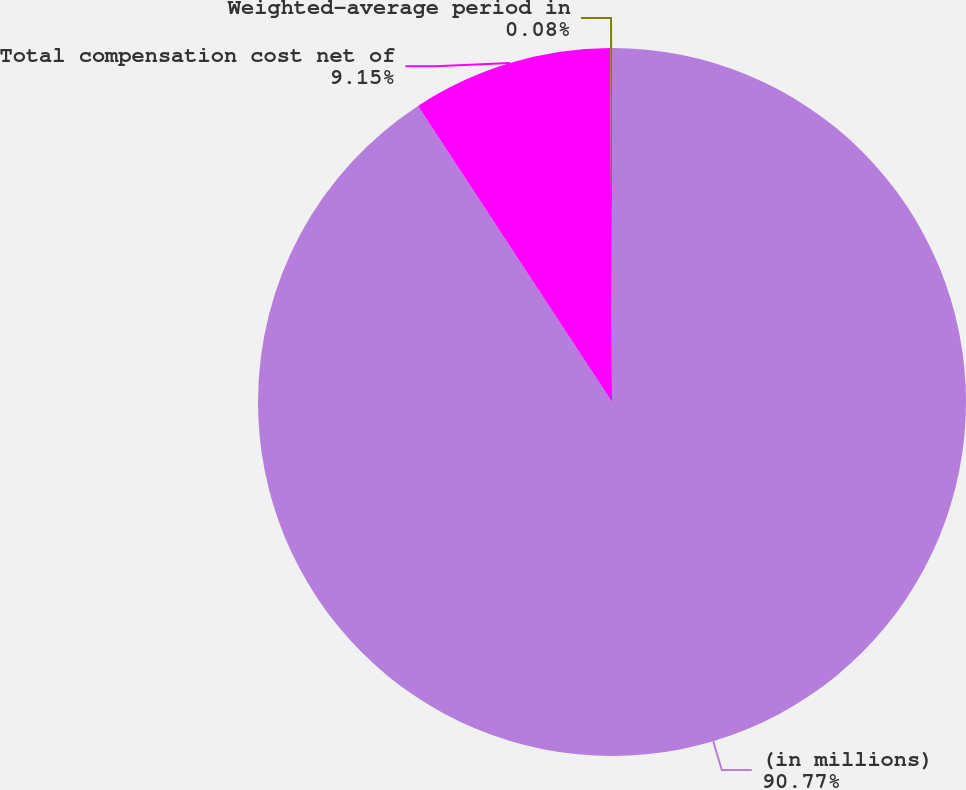Convert chart. <chart><loc_0><loc_0><loc_500><loc_500><pie_chart><fcel>(in millions)<fcel>Total compensation cost net of<fcel>Weighted-average period in<nl><fcel>90.77%<fcel>9.15%<fcel>0.08%<nl></chart> 